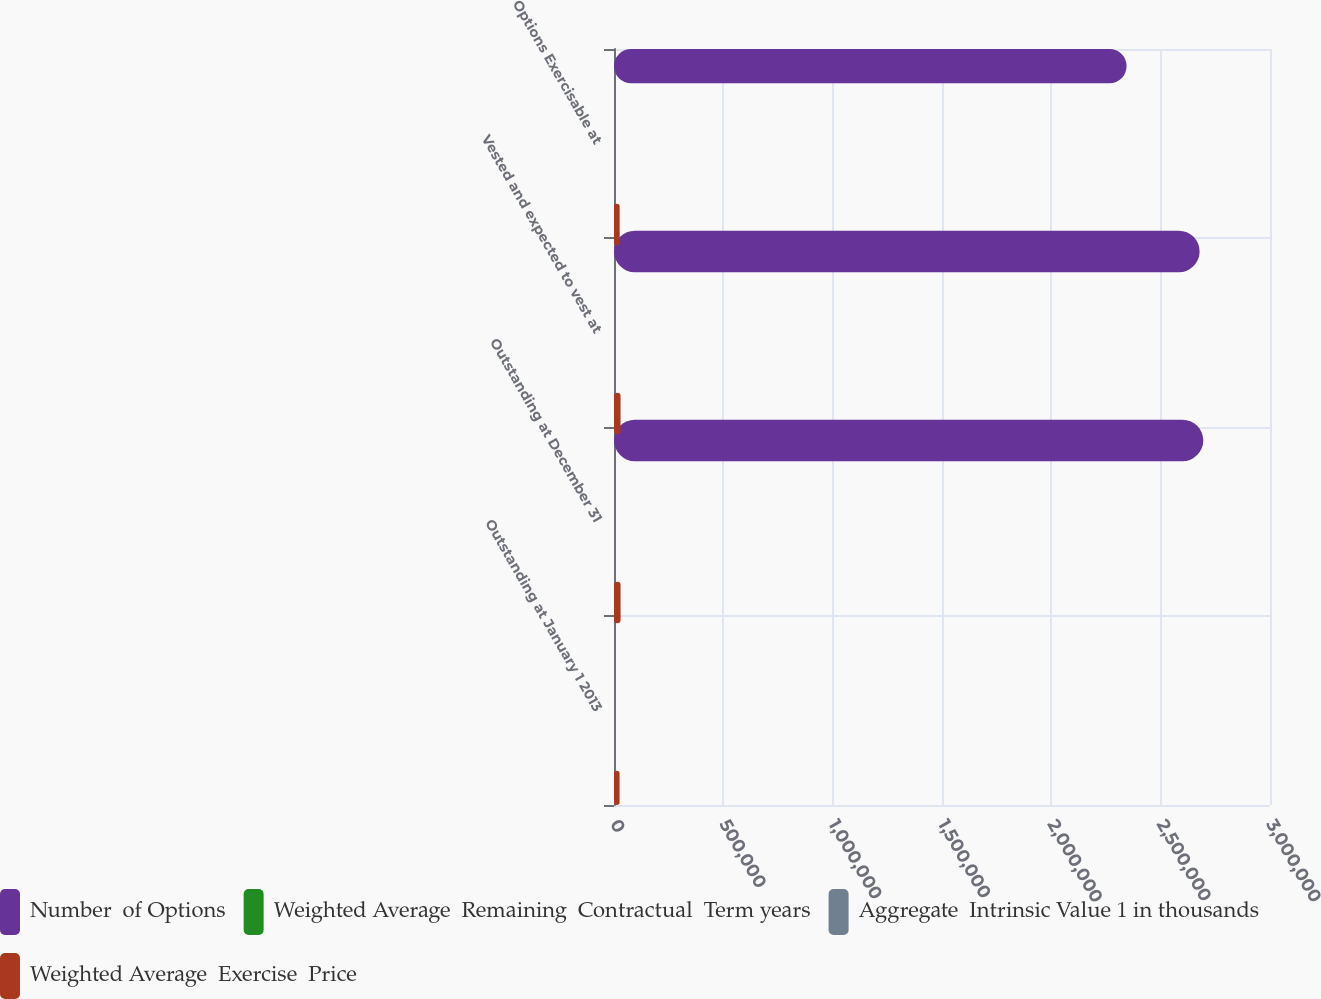Convert chart. <chart><loc_0><loc_0><loc_500><loc_500><stacked_bar_chart><ecel><fcel>Outstanding at January 1 2013<fcel>Outstanding at December 31<fcel>Vested and expected to vest at<fcel>Options Exercisable at<nl><fcel>Number  of Options<fcel>36.42<fcel>2.69487e+06<fcel>2.67816e+06<fcel>2.34412e+06<nl><fcel>Weighted Average  Remaining  Contractual  Term years<fcel>33.56<fcel>36.3<fcel>36.27<fcel>36.42<nl><fcel>Aggregate  Intrinsic Value 1 in thousands<fcel>4.55<fcel>3.83<fcel>3.81<fcel>3.41<nl><fcel>Weighted Average  Exercise  Price<fcel>25522<fcel>30080<fcel>29978<fcel>25914<nl></chart> 